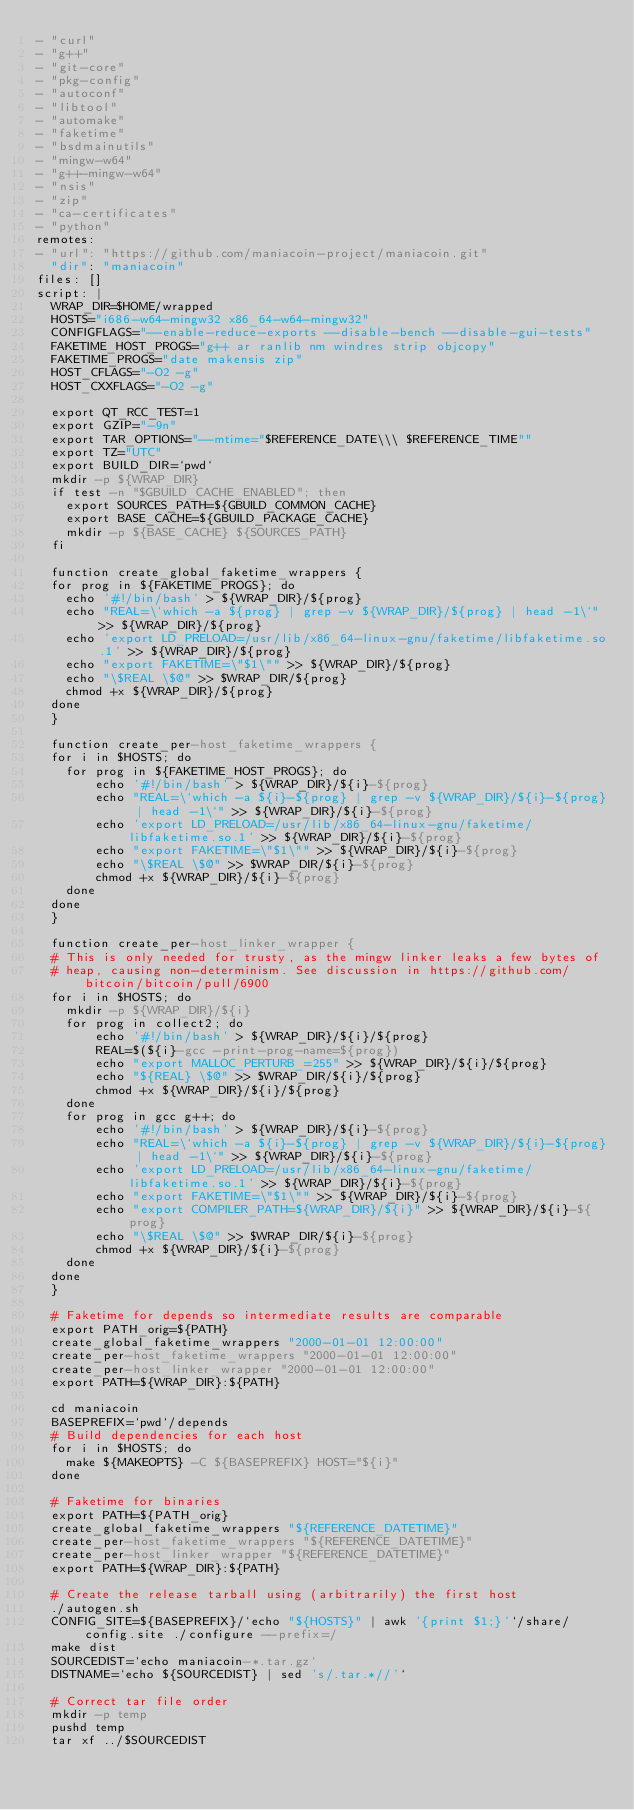<code> <loc_0><loc_0><loc_500><loc_500><_YAML_>- "curl"
- "g++"
- "git-core"
- "pkg-config"
- "autoconf"
- "libtool"
- "automake"
- "faketime"
- "bsdmainutils"
- "mingw-w64"
- "g++-mingw-w64"
- "nsis"
- "zip"
- "ca-certificates"
- "python"
remotes:
- "url": "https://github.com/maniacoin-project/maniacoin.git"
  "dir": "maniacoin"
files: []
script: |
  WRAP_DIR=$HOME/wrapped
  HOSTS="i686-w64-mingw32 x86_64-w64-mingw32"
  CONFIGFLAGS="--enable-reduce-exports --disable-bench --disable-gui-tests"
  FAKETIME_HOST_PROGS="g++ ar ranlib nm windres strip objcopy"
  FAKETIME_PROGS="date makensis zip"
  HOST_CFLAGS="-O2 -g"
  HOST_CXXFLAGS="-O2 -g"

  export QT_RCC_TEST=1
  export GZIP="-9n"
  export TAR_OPTIONS="--mtime="$REFERENCE_DATE\\\ $REFERENCE_TIME""
  export TZ="UTC"
  export BUILD_DIR=`pwd`
  mkdir -p ${WRAP_DIR}
  if test -n "$GBUILD_CACHE_ENABLED"; then
    export SOURCES_PATH=${GBUILD_COMMON_CACHE}
    export BASE_CACHE=${GBUILD_PACKAGE_CACHE}
    mkdir -p ${BASE_CACHE} ${SOURCES_PATH}
  fi

  function create_global_faketime_wrappers {
  for prog in ${FAKETIME_PROGS}; do
    echo '#!/bin/bash' > ${WRAP_DIR}/${prog}
    echo "REAL=\`which -a ${prog} | grep -v ${WRAP_DIR}/${prog} | head -1\`" >> ${WRAP_DIR}/${prog}
    echo 'export LD_PRELOAD=/usr/lib/x86_64-linux-gnu/faketime/libfaketime.so.1' >> ${WRAP_DIR}/${prog}
    echo "export FAKETIME=\"$1\"" >> ${WRAP_DIR}/${prog}
    echo "\$REAL \$@" >> $WRAP_DIR/${prog}
    chmod +x ${WRAP_DIR}/${prog}
  done
  }

  function create_per-host_faketime_wrappers {
  for i in $HOSTS; do
    for prog in ${FAKETIME_HOST_PROGS}; do
        echo '#!/bin/bash' > ${WRAP_DIR}/${i}-${prog}
        echo "REAL=\`which -a ${i}-${prog} | grep -v ${WRAP_DIR}/${i}-${prog} | head -1\`" >> ${WRAP_DIR}/${i}-${prog}
        echo 'export LD_PRELOAD=/usr/lib/x86_64-linux-gnu/faketime/libfaketime.so.1' >> ${WRAP_DIR}/${i}-${prog}
        echo "export FAKETIME=\"$1\"" >> ${WRAP_DIR}/${i}-${prog}
        echo "\$REAL \$@" >> $WRAP_DIR/${i}-${prog}
        chmod +x ${WRAP_DIR}/${i}-${prog}
    done
  done
  }

  function create_per-host_linker_wrapper {
  # This is only needed for trusty, as the mingw linker leaks a few bytes of
  # heap, causing non-determinism. See discussion in https://github.com/bitcoin/bitcoin/pull/6900
  for i in $HOSTS; do
    mkdir -p ${WRAP_DIR}/${i}
    for prog in collect2; do
        echo '#!/bin/bash' > ${WRAP_DIR}/${i}/${prog}
        REAL=$(${i}-gcc -print-prog-name=${prog})
        echo "export MALLOC_PERTURB_=255" >> ${WRAP_DIR}/${i}/${prog}
        echo "${REAL} \$@" >> $WRAP_DIR/${i}/${prog}
        chmod +x ${WRAP_DIR}/${i}/${prog}
    done
    for prog in gcc g++; do
        echo '#!/bin/bash' > ${WRAP_DIR}/${i}-${prog}
        echo "REAL=\`which -a ${i}-${prog} | grep -v ${WRAP_DIR}/${i}-${prog} | head -1\`" >> ${WRAP_DIR}/${i}-${prog}
        echo 'export LD_PRELOAD=/usr/lib/x86_64-linux-gnu/faketime/libfaketime.so.1' >> ${WRAP_DIR}/${i}-${prog}
        echo "export FAKETIME=\"$1\"" >> ${WRAP_DIR}/${i}-${prog}
        echo "export COMPILER_PATH=${WRAP_DIR}/${i}" >> ${WRAP_DIR}/${i}-${prog}
        echo "\$REAL \$@" >> $WRAP_DIR/${i}-${prog}
        chmod +x ${WRAP_DIR}/${i}-${prog}
    done
  done
  }

  # Faketime for depends so intermediate results are comparable
  export PATH_orig=${PATH}
  create_global_faketime_wrappers "2000-01-01 12:00:00"
  create_per-host_faketime_wrappers "2000-01-01 12:00:00"
  create_per-host_linker_wrapper "2000-01-01 12:00:00"
  export PATH=${WRAP_DIR}:${PATH}

  cd maniacoin
  BASEPREFIX=`pwd`/depends
  # Build dependencies for each host
  for i in $HOSTS; do
    make ${MAKEOPTS} -C ${BASEPREFIX} HOST="${i}"
  done

  # Faketime for binaries
  export PATH=${PATH_orig}
  create_global_faketime_wrappers "${REFERENCE_DATETIME}"
  create_per-host_faketime_wrappers "${REFERENCE_DATETIME}"
  create_per-host_linker_wrapper "${REFERENCE_DATETIME}"
  export PATH=${WRAP_DIR}:${PATH}

  # Create the release tarball using (arbitrarily) the first host
  ./autogen.sh
  CONFIG_SITE=${BASEPREFIX}/`echo "${HOSTS}" | awk '{print $1;}'`/share/config.site ./configure --prefix=/
  make dist
  SOURCEDIST=`echo maniacoin-*.tar.gz`
  DISTNAME=`echo ${SOURCEDIST} | sed 's/.tar.*//'`

  # Correct tar file order
  mkdir -p temp
  pushd temp
  tar xf ../$SOURCEDIST</code> 